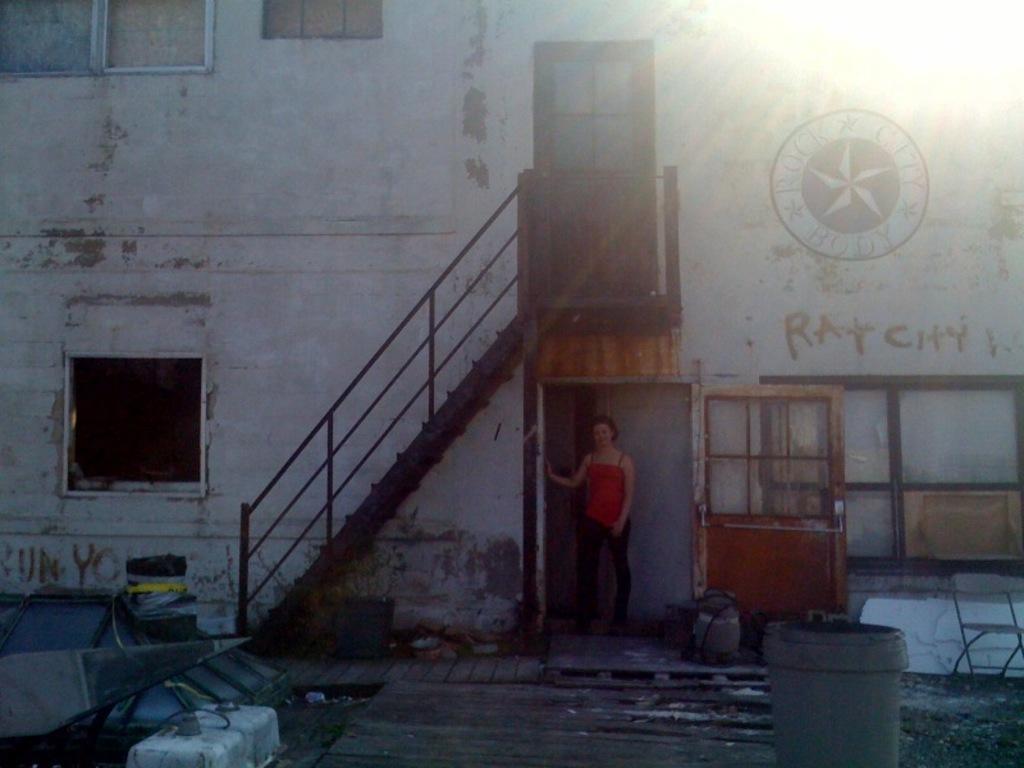Describe this image in one or two sentences. In this picture there is a woman wearing red dress is standing and there is a staircase above her and there is a building in the background and there is a window and some other objects in the right corner and there are some other objects in the left corner. 